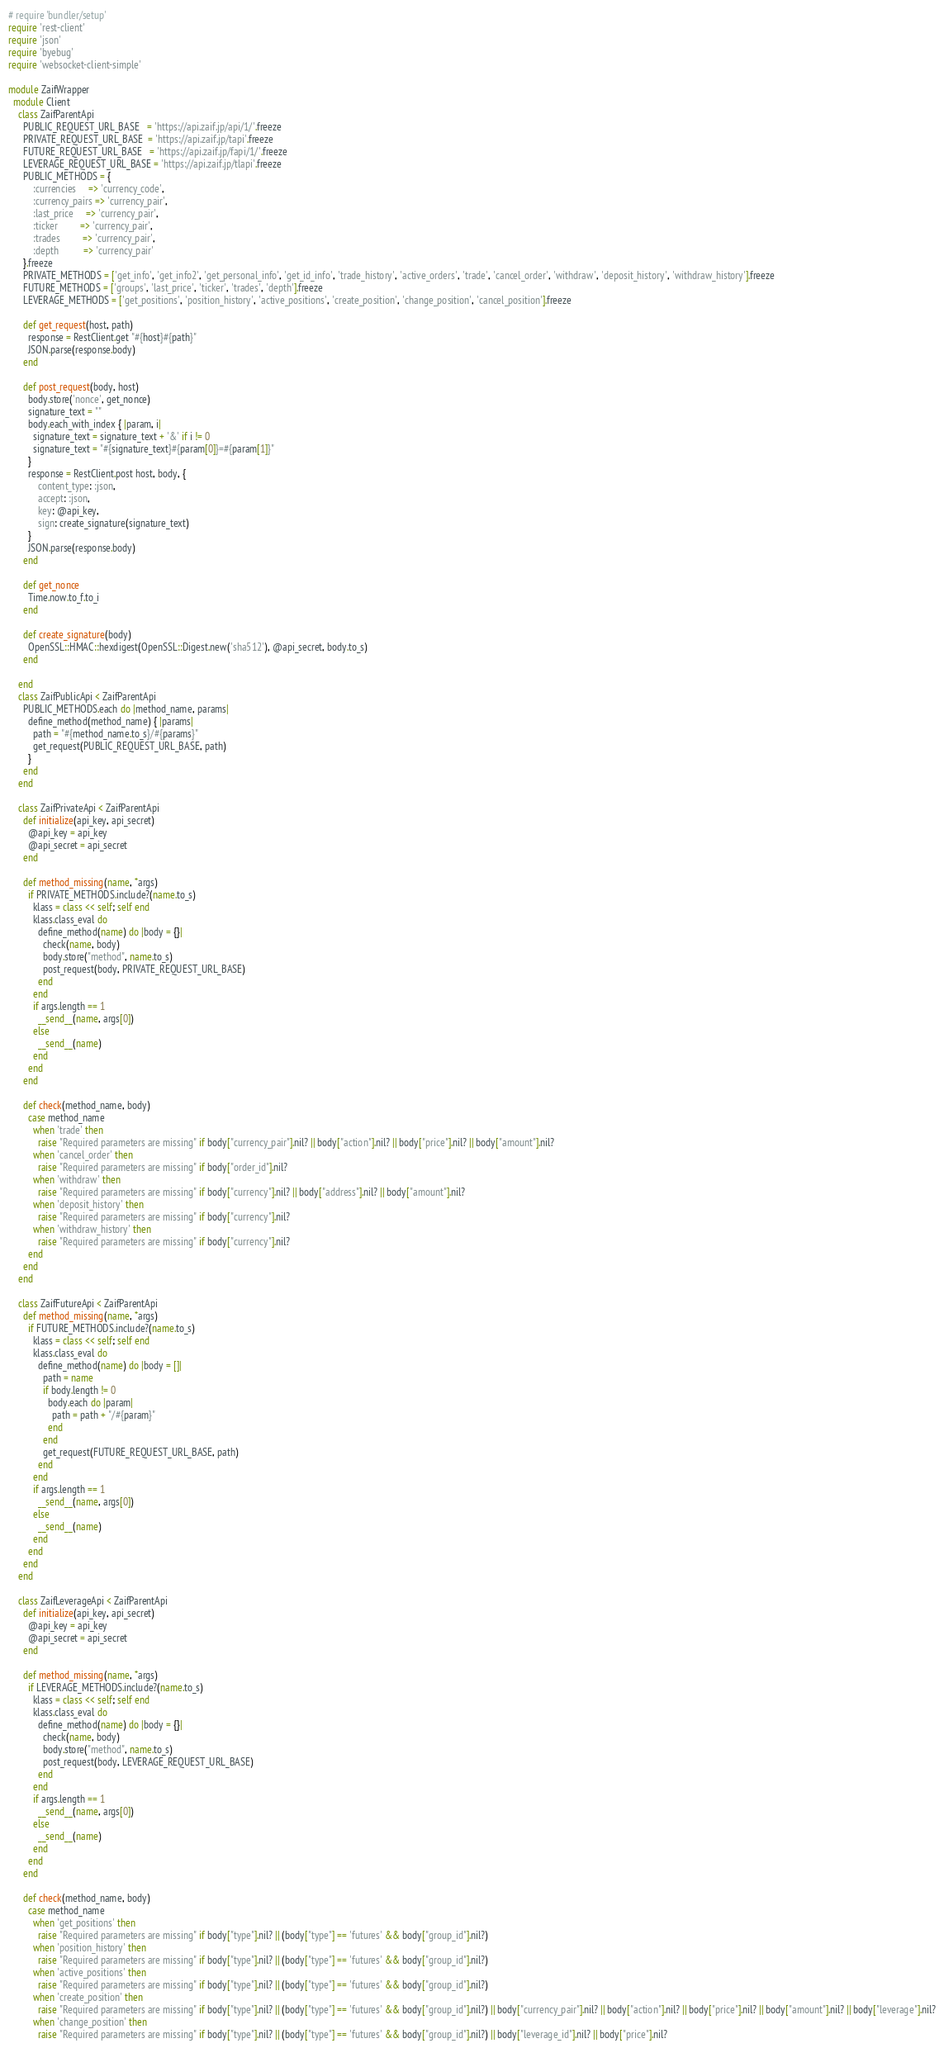Convert code to text. <code><loc_0><loc_0><loc_500><loc_500><_Ruby_># require 'bundler/setup'
require 'rest-client'
require 'json'
require 'byebug'
require 'websocket-client-simple'

module ZaifWrapper
  module Client
    class ZaifParentApi
      PUBLIC_REQUEST_URL_BASE   = 'https://api.zaif.jp/api/1/'.freeze
      PRIVATE_REQUEST_URL_BASE  = 'https://api.zaif.jp/tapi'.freeze
      FUTURE_REQUEST_URL_BASE   = 'https://api.zaif.jp/fapi/1/'.freeze
      LEVERAGE_REQUEST_URL_BASE = 'https://api.zaif.jp/tlapi'.freeze
      PUBLIC_METHODS = {
          :currencies     => 'currency_code',
          :currency_pairs => 'currency_pair',
          :last_price     => 'currency_pair',
          :ticker         => 'currency_pair',
          :trades         => 'currency_pair',
          :depth          => 'currency_pair'
      }.freeze
      PRIVATE_METHODS = ['get_info', 'get_info2', 'get_personal_info', 'get_id_info', 'trade_history', 'active_orders', 'trade', 'cancel_order', 'withdraw', 'deposit_history', 'withdraw_history'].freeze
      FUTURE_METHODS = ['groups', 'last_price', 'ticker', 'trades', 'depth'].freeze
      LEVERAGE_METHODS = ['get_positions', 'position_history', 'active_positions', 'create_position', 'change_position', 'cancel_position'].freeze

      def get_request(host, path)
        response = RestClient.get "#{host}#{path}"
        JSON.parse(response.body)
      end

      def post_request(body, host)
        body.store('nonce', get_nonce)
        signature_text = ""
        body.each_with_index { |param, i|
          signature_text = signature_text + '&' if i != 0
          signature_text = "#{signature_text}#{param[0]}=#{param[1]}"
        }
        response = RestClient.post host, body, {
            content_type: :json,
            accept: :json,
            key: @api_key,
            sign: create_signature(signature_text)
        }
        JSON.parse(response.body)
      end

      def get_nonce
        Time.now.to_f.to_i
      end

      def create_signature(body)
        OpenSSL::HMAC::hexdigest(OpenSSL::Digest.new('sha512'), @api_secret, body.to_s)
      end

    end
    class ZaifPublicApi < ZaifParentApi
      PUBLIC_METHODS.each do |method_name, params|
        define_method(method_name) { |params|
          path = "#{method_name.to_s}/#{params}"
          get_request(PUBLIC_REQUEST_URL_BASE, path)
        }
      end
    end

    class ZaifPrivateApi < ZaifParentApi
      def initialize(api_key, api_secret)
        @api_key = api_key
        @api_secret = api_secret
      end

      def method_missing(name, *args)
        if PRIVATE_METHODS.include?(name.to_s)
          klass = class << self; self end
          klass.class_eval do
            define_method(name) do |body = {}|
              check(name, body)
              body.store("method", name.to_s)
              post_request(body, PRIVATE_REQUEST_URL_BASE)
            end
          end
          if args.length == 1
            __send__(name, args[0])
          else
            __send__(name)
          end
        end
      end

      def check(method_name, body)
        case method_name
          when 'trade' then
            raise "Required parameters are missing" if body["currency_pair"].nil? || body["action"].nil? || body["price"].nil? || body["amount"].nil?
          when 'cancel_order' then
            raise "Required parameters are missing" if body["order_id"].nil?
          when 'withdraw' then
            raise "Required parameters are missing" if body["currency"].nil? || body["address"].nil? || body["amount"].nil?
          when 'deposit_history' then
            raise "Required parameters are missing" if body["currency"].nil?
          when 'withdraw_history' then
            raise "Required parameters are missing" if body["currency"].nil?
        end
      end
    end

    class ZaifFutureApi < ZaifParentApi
      def method_missing(name, *args)
        if FUTURE_METHODS.include?(name.to_s)
          klass = class << self; self end
          klass.class_eval do
            define_method(name) do |body = []|
              path = name
              if body.length != 0
                body.each do |param|
                  path = path + "/#{param}"
                end
              end
              get_request(FUTURE_REQUEST_URL_BASE, path)
            end
          end
          if args.length == 1
            __send__(name, args[0])
          else
            __send__(name)
          end
        end
      end
    end

    class ZaifLeverageApi < ZaifParentApi
      def initialize(api_key, api_secret)
        @api_key = api_key
        @api_secret = api_secret
      end

      def method_missing(name, *args)
        if LEVERAGE_METHODS.include?(name.to_s)
          klass = class << self; self end
          klass.class_eval do
            define_method(name) do |body = {}|
              check(name, body)
              body.store("method", name.to_s)
              post_request(body, LEVERAGE_REQUEST_URL_BASE)
            end
          end
          if args.length == 1
            __send__(name, args[0])
          else
            __send__(name)
          end
        end
      end

      def check(method_name, body)
        case method_name
          when 'get_positions' then
            raise "Required parameters are missing" if body["type"].nil? || (body["type"] == 'futures' && body["group_id"].nil?)
          when 'position_history' then
            raise "Required parameters are missing" if body["type"].nil? || (body["type"] == 'futures' && body["group_id"].nil?)
          when 'active_positions' then
            raise "Required parameters are missing" if body["type"].nil? || (body["type"] == 'futures' && body["group_id"].nil?)
          when 'create_position' then
            raise "Required parameters are missing" if body["type"].nil? || (body["type"] == 'futures' && body["group_id"].nil?) || body["currency_pair"].nil? || body["action"].nil? || body["price"].nil? || body["amount"].nil? || body["leverage"].nil?
          when 'change_position' then
            raise "Required parameters are missing" if body["type"].nil? || (body["type"] == 'futures' && body["group_id"].nil?) || body["leverage_id"].nil? || body["price"].nil?</code> 